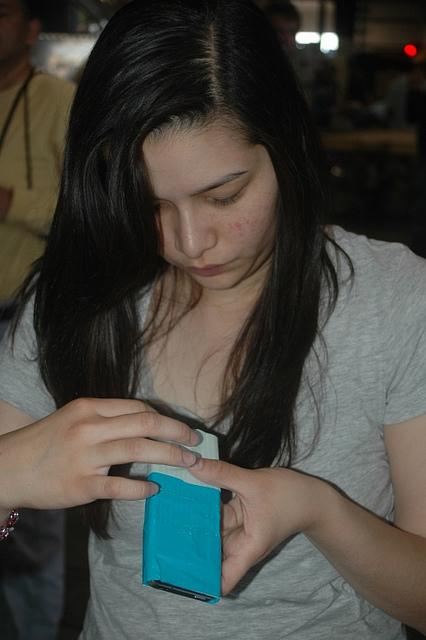Is this girl happy?
Quick response, please. No. Is this lady smiling?
Concise answer only. No. How tall is the woman?
Short answer required. Short. What color is her shirt?
Write a very short answer. Gray. What is the woman holding in her hands?
Answer briefly. Phone. What color is the device she is holding?
Be succinct. Blue. Is the phone on?
Quick response, please. No. Is the woman looking up?
Write a very short answer. No. Is she smiling?
Quick response, please. No. What is the color of the woman hair?
Quick response, please. Black. Is the girl wearing a hat?
Answer briefly. No. What color of hair does the girl have?
Be succinct. Black. What medical condition affects the woman's face?
Keep it brief. Acne. Is the phone a flip phone or smartphone?
Concise answer only. Smartphone. 